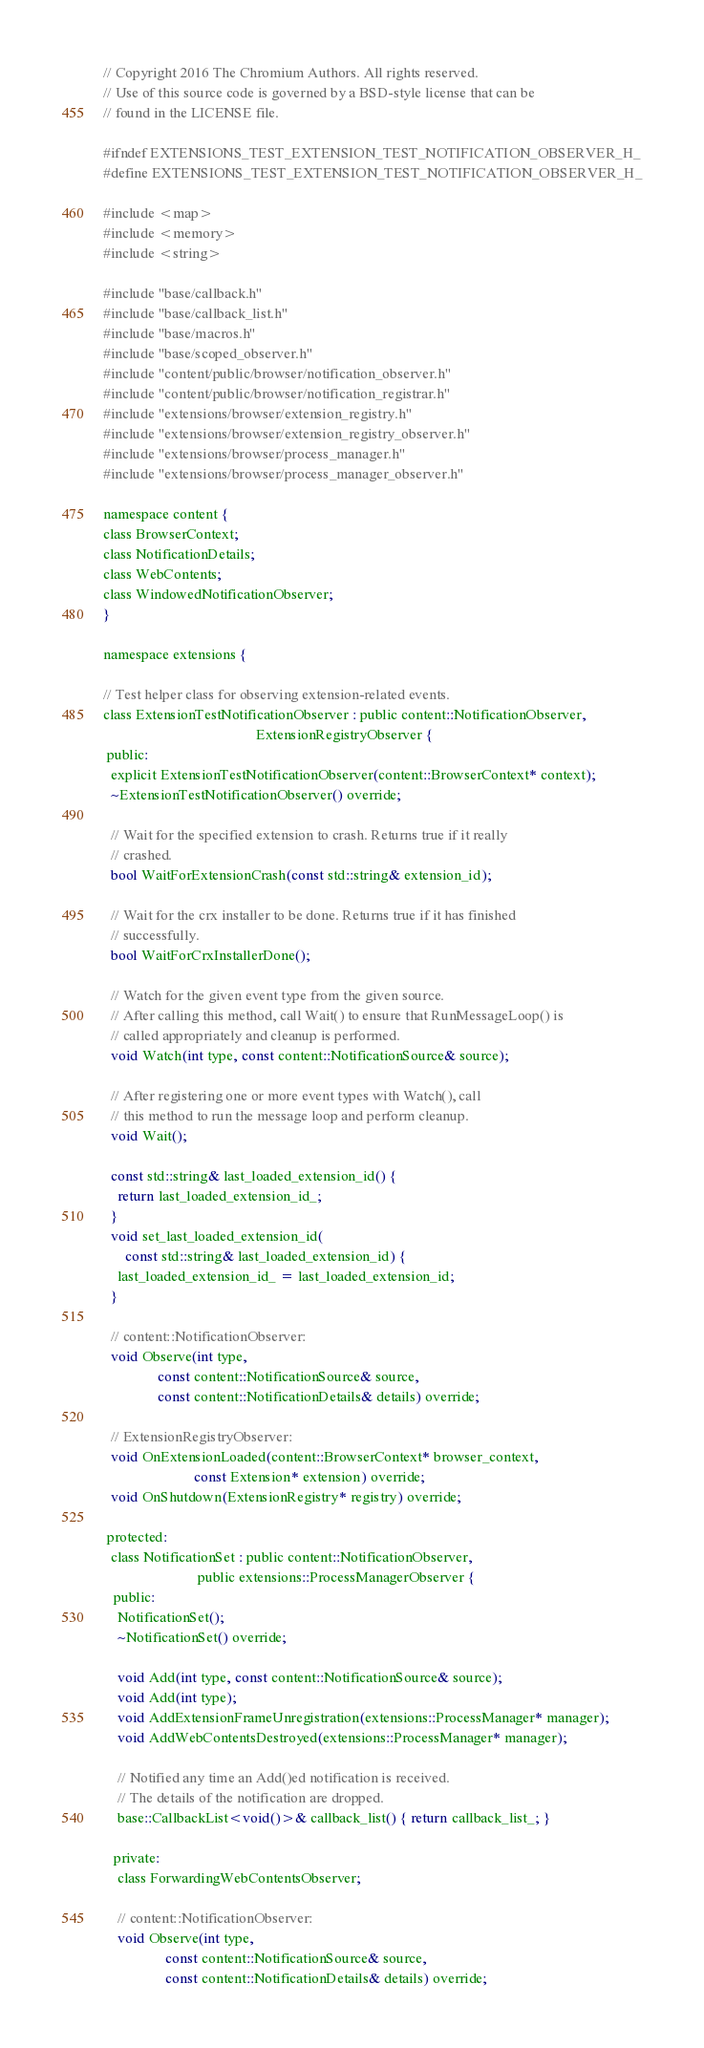Convert code to text. <code><loc_0><loc_0><loc_500><loc_500><_C_>// Copyright 2016 The Chromium Authors. All rights reserved.
// Use of this source code is governed by a BSD-style license that can be
// found in the LICENSE file.

#ifndef EXTENSIONS_TEST_EXTENSION_TEST_NOTIFICATION_OBSERVER_H_
#define EXTENSIONS_TEST_EXTENSION_TEST_NOTIFICATION_OBSERVER_H_

#include <map>
#include <memory>
#include <string>

#include "base/callback.h"
#include "base/callback_list.h"
#include "base/macros.h"
#include "base/scoped_observer.h"
#include "content/public/browser/notification_observer.h"
#include "content/public/browser/notification_registrar.h"
#include "extensions/browser/extension_registry.h"
#include "extensions/browser/extension_registry_observer.h"
#include "extensions/browser/process_manager.h"
#include "extensions/browser/process_manager_observer.h"

namespace content {
class BrowserContext;
class NotificationDetails;
class WebContents;
class WindowedNotificationObserver;
}

namespace extensions {

// Test helper class for observing extension-related events.
class ExtensionTestNotificationObserver : public content::NotificationObserver,
                                          ExtensionRegistryObserver {
 public:
  explicit ExtensionTestNotificationObserver(content::BrowserContext* context);
  ~ExtensionTestNotificationObserver() override;

  // Wait for the specified extension to crash. Returns true if it really
  // crashed.
  bool WaitForExtensionCrash(const std::string& extension_id);

  // Wait for the crx installer to be done. Returns true if it has finished
  // successfully.
  bool WaitForCrxInstallerDone();

  // Watch for the given event type from the given source.
  // After calling this method, call Wait() to ensure that RunMessageLoop() is
  // called appropriately and cleanup is performed.
  void Watch(int type, const content::NotificationSource& source);

  // After registering one or more event types with Watch(), call
  // this method to run the message loop and perform cleanup.
  void Wait();

  const std::string& last_loaded_extension_id() {
    return last_loaded_extension_id_;
  }
  void set_last_loaded_extension_id(
      const std::string& last_loaded_extension_id) {
    last_loaded_extension_id_ = last_loaded_extension_id;
  }

  // content::NotificationObserver:
  void Observe(int type,
               const content::NotificationSource& source,
               const content::NotificationDetails& details) override;

  // ExtensionRegistryObserver:
  void OnExtensionLoaded(content::BrowserContext* browser_context,
                         const Extension* extension) override;
  void OnShutdown(ExtensionRegistry* registry) override;

 protected:
  class NotificationSet : public content::NotificationObserver,
                          public extensions::ProcessManagerObserver {
   public:
    NotificationSet();
    ~NotificationSet() override;

    void Add(int type, const content::NotificationSource& source);
    void Add(int type);
    void AddExtensionFrameUnregistration(extensions::ProcessManager* manager);
    void AddWebContentsDestroyed(extensions::ProcessManager* manager);

    // Notified any time an Add()ed notification is received.
    // The details of the notification are dropped.
    base::CallbackList<void()>& callback_list() { return callback_list_; }

   private:
    class ForwardingWebContentsObserver;

    // content::NotificationObserver:
    void Observe(int type,
                 const content::NotificationSource& source,
                 const content::NotificationDetails& details) override;
</code> 